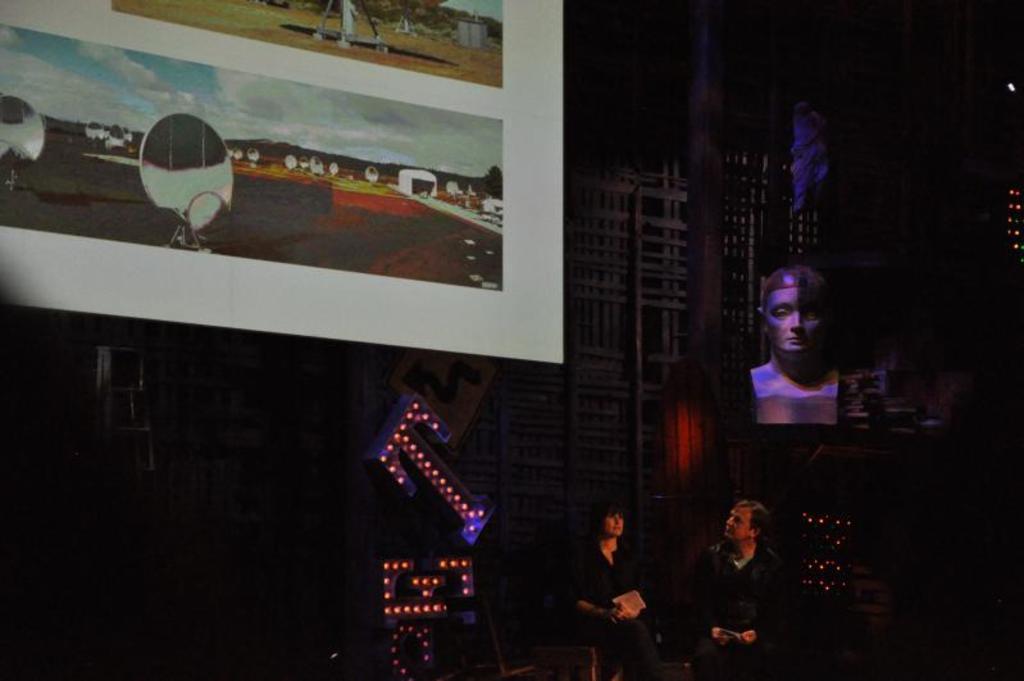Please provide a concise description of this image. In this image I can see a man and a woman are sitting. Here I can see board which has some pictures on it. On the right side I can see a statue and some other objects. 